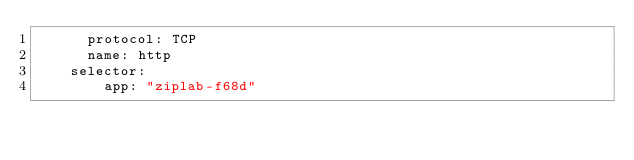Convert code to text. <code><loc_0><loc_0><loc_500><loc_500><_YAML_>      protocol: TCP
      name: http
    selector:
        app: "ziplab-f68d"</code> 